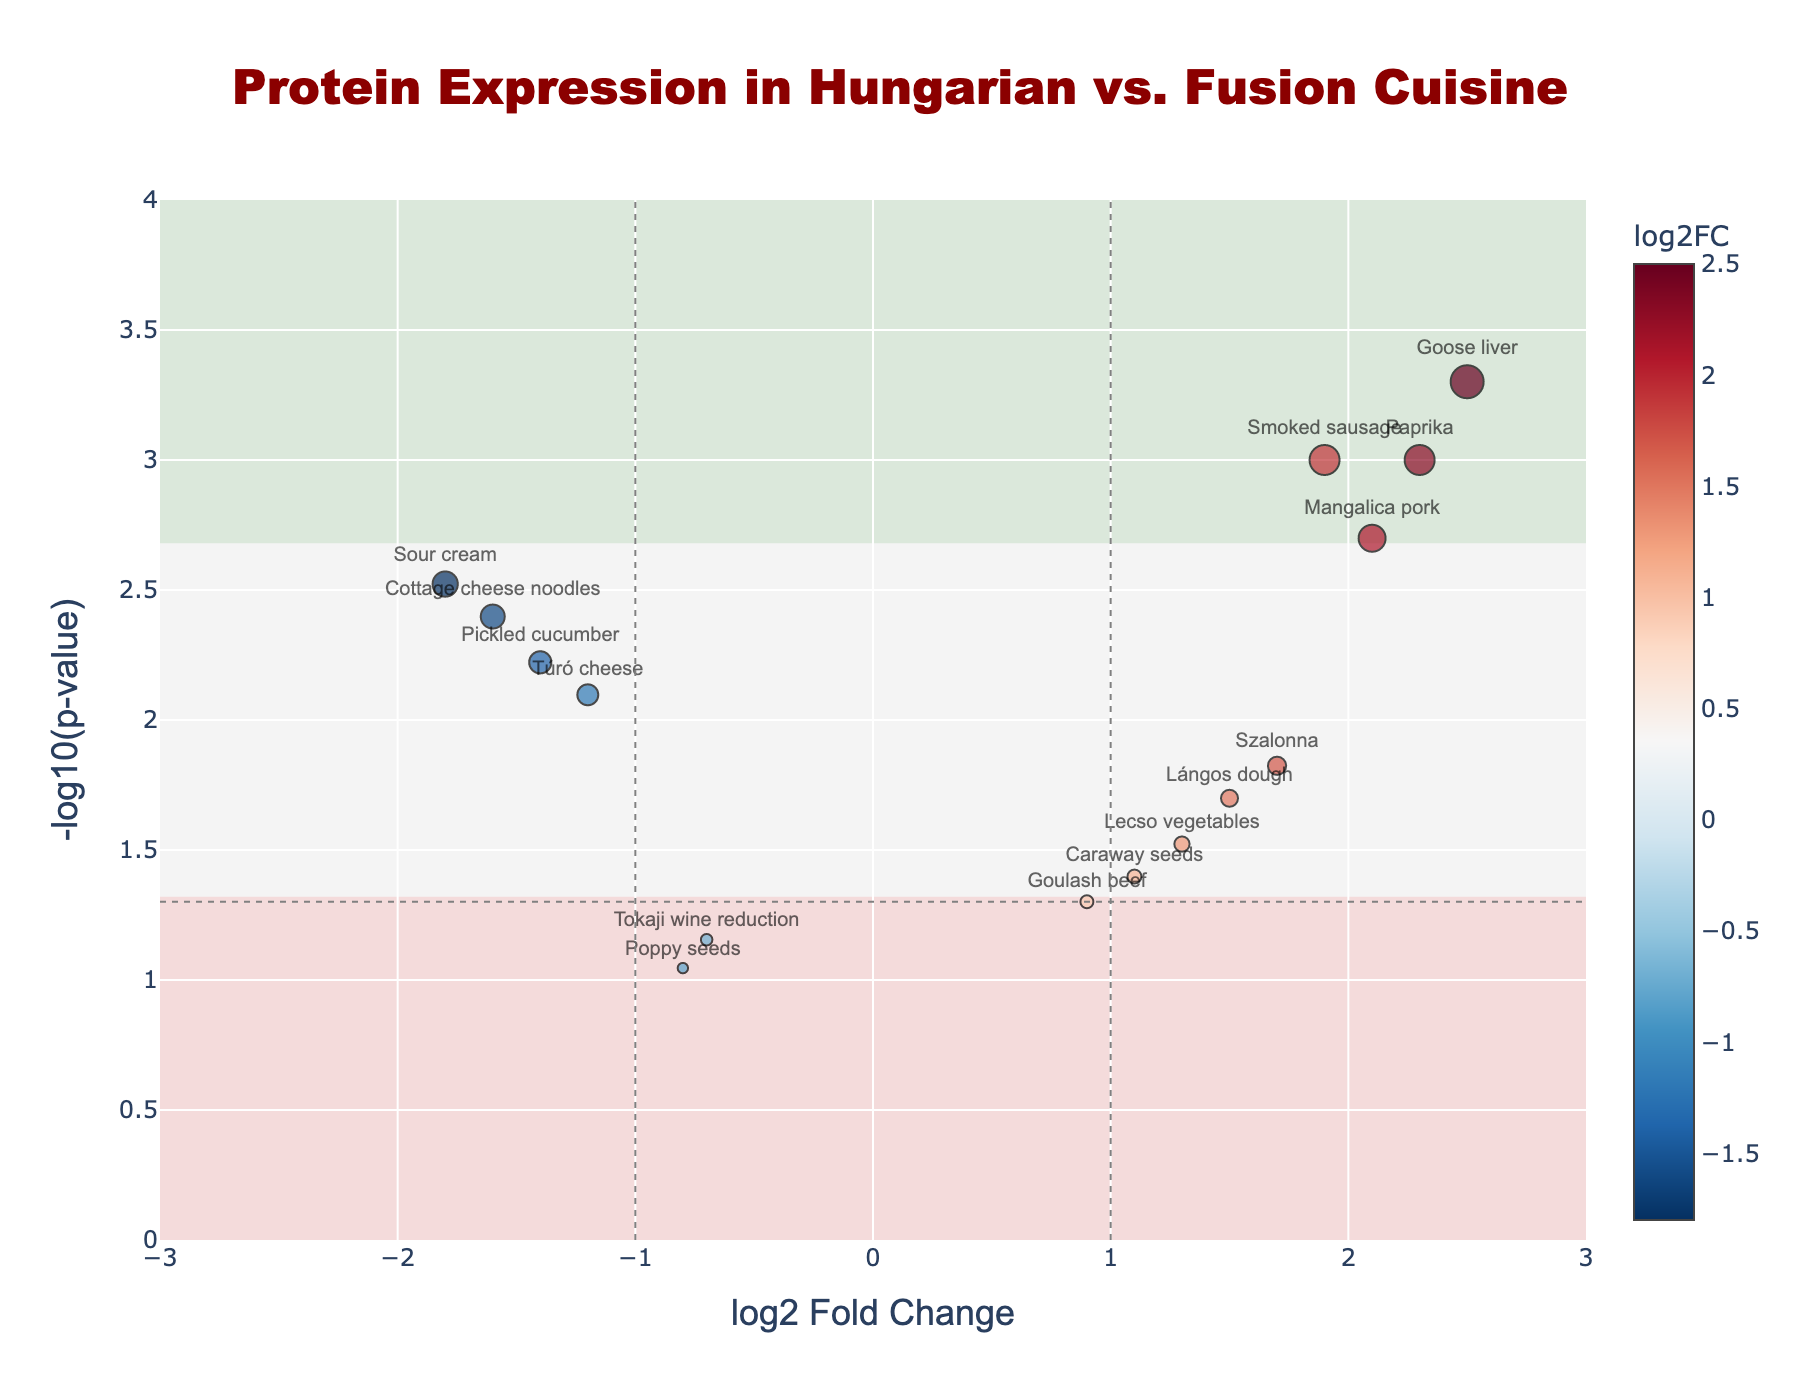What are the axes titles in the figure? The horizontal axis title is "log2 Fold Change," and the vertical axis title is "-log10(p-value)." These titles indicate the key metrics being compared in the Volcano Plot: the logarithm of fold changes in protein expression and the negative logarithm of p-values which reflect the significance of those changes.
Answer: "log2 Fold Change" and "-log10(p-value)" How many proteins have a log2 Fold Change greater than 1? To answer, we look at the horizontal axis and count the points to the right of the vertical dashed line at x=1. There are points for Paprika, Mangalica pork, Goose liver, and Smoked sausage, which make up four proteins.
Answer: 4 Which protein has the highest significance (smallest p-value)? The most significant protein will appear highest on the vertical axis due to the -log10(p-value) transformation. Goose liver has the highest vertical position, indicating it has the smallest p-value.
Answer: Goose liver Which proteins are upregulated in traditional Hungarian cuisine compared to international fusion dishes? Upregulated proteins have positive log2 Fold Changes. The points to the right side of the plot (positive x-values) represent these proteins: Paprika, Lángos dough, Goulash beef, Mangalica pork, Szalonna, Caraway seeds, Lecso vegetables, and Smoked sausage.
Answer: Paprika, Lángos dough, Goulash beef, Mangalica pork, Szalonna, Caraway seeds, Lecso vegetables, Smoked sausage Which proteins are downregulated and have high statistical significance (p-value < 0.05)? Downregulated proteins have negative log2 Fold Changes and, with high significance, will appear below the p-value threshold line of 0.05. These proteins are Sour cream, Túró cheese, Pickled cucumber, and Cottage cheese noodles.
Answer: Sour cream, Túró cheese, Pickled cucumber, Cottage cheese noodles What is the log2 Fold Change of Mangalica pork, and is it statistically significant? To answer this, locate Mangalica pork on the plot. Its x-coordinate represents log2 Fold Change. Mangalica pork has a log2 Fold Change of 2.1 and is above the y=-log10(0.05) significance line, indicating it's statistically significant.
Answer: 2.1 and yes Compare the log2 Fold Changes of Paprika and Sour cream. Which is higher? Paprika has a log2 Fold Change of 2.3, while Sour cream has -1.8. Comparing these values, 2.3 is higher than -1.8.
Answer: Paprika How many proteins have a p-value greater than 0.05? P-values greater than 0.05 will place points below the horizontal dashed line at y=-log10(0.05) on the vertical axis. Only Tokaji wine reduction and Poppy seeds are below this line, making two proteins.
Answer: 2 What is the range of log2 Fold Changes for Goulash beef and Cottage cheese noodles? Goulash beef has a log2 Fold Change of 0.9, and Cottage cheese noodles have -1.6. The difference is calculated as 0.9 - (-1.6) = 2.5.
Answer: 2.5 